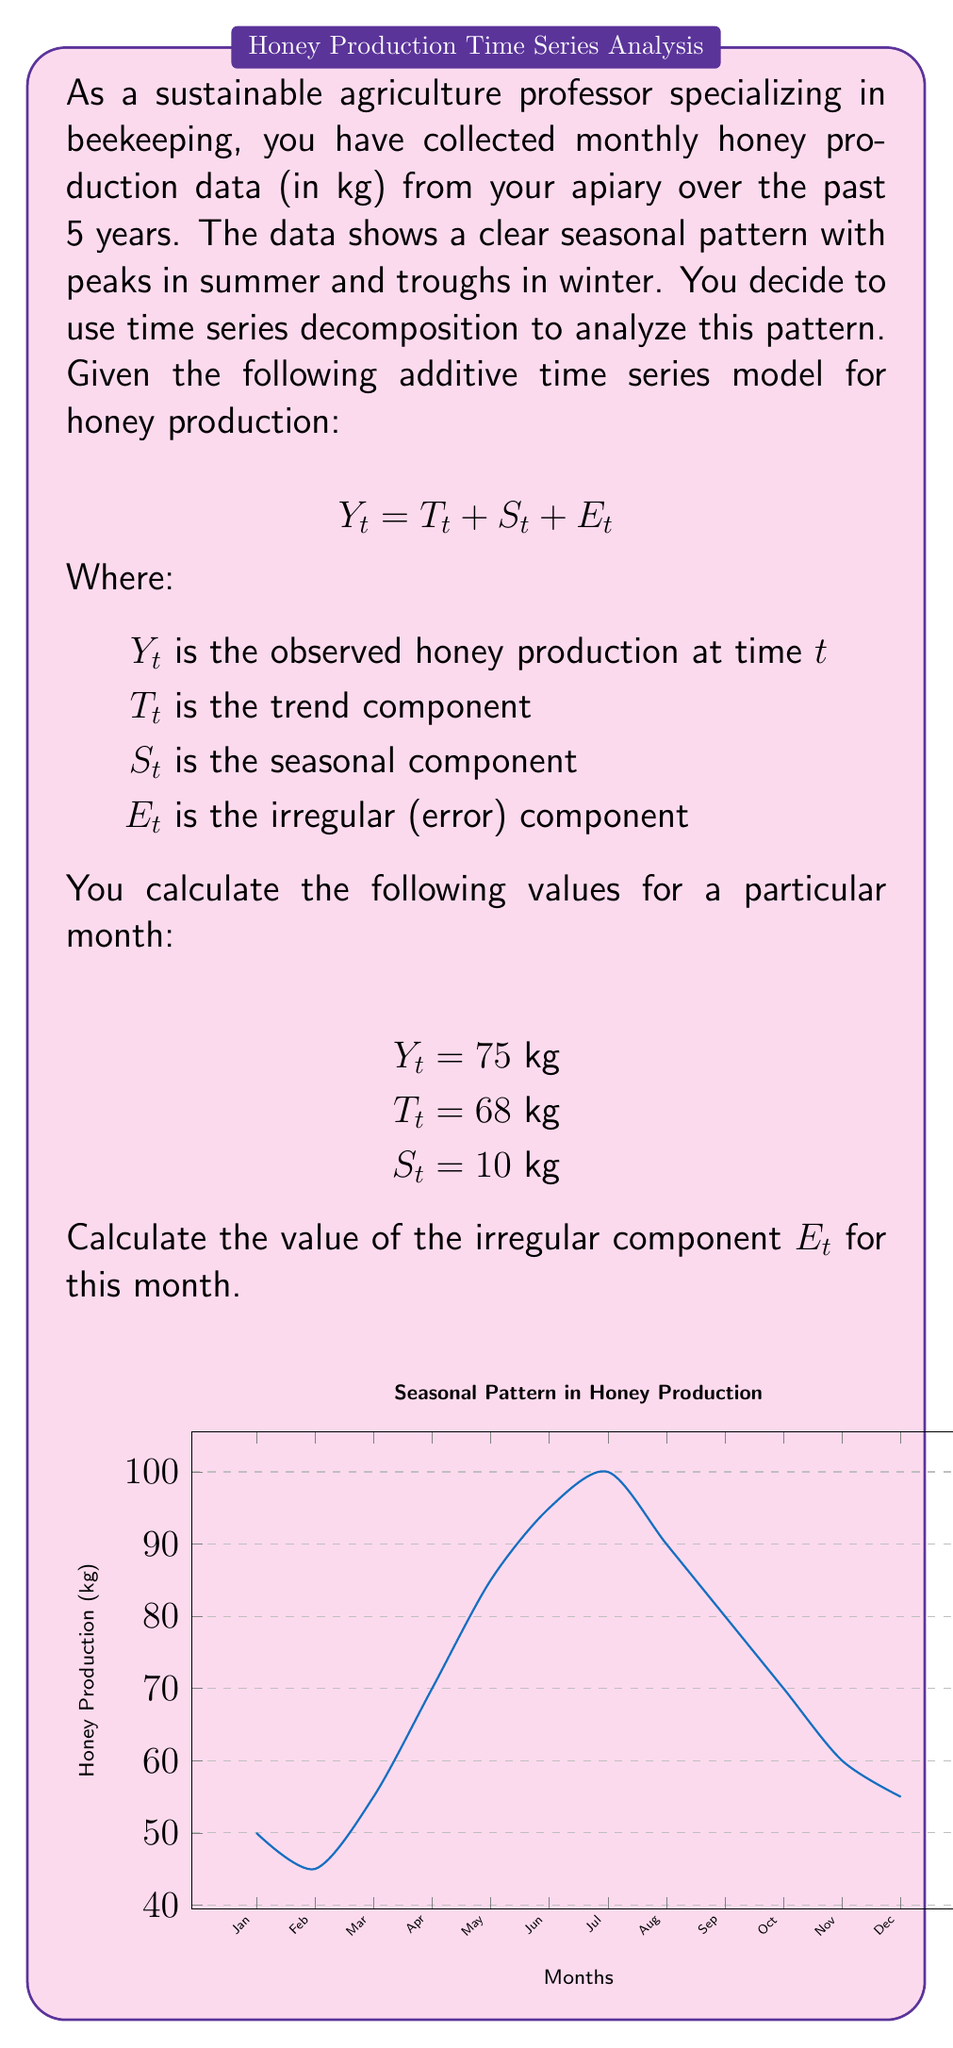Can you solve this math problem? To solve this problem, we need to use the additive time series decomposition model:

$$Y_t = T_t + S_t + E_t$$

We are given the values for $Y_t$, $T_t$, and $S_t$. To find $E_t$, we need to rearrange the equation:

$$E_t = Y_t - T_t - S_t$$

Now, let's substitute the known values:

1) Observed honey production ($Y_t$) = 75 kg
2) Trend component ($T_t$) = 68 kg
3) Seasonal component ($S_t$) = 10 kg

$$E_t = 75 - 68 - 10$$

$$E_t = -3$$

Therefore, the irregular component $E_t$ for this month is -3 kg.

This negative value indicates that the actual honey production for this month was slightly lower than what would be expected based on the trend and seasonal components alone. This could be due to various factors such as weather anomalies, pest issues, or other unexpected events affecting honey production.
Answer: $E_t = -3$ kg 